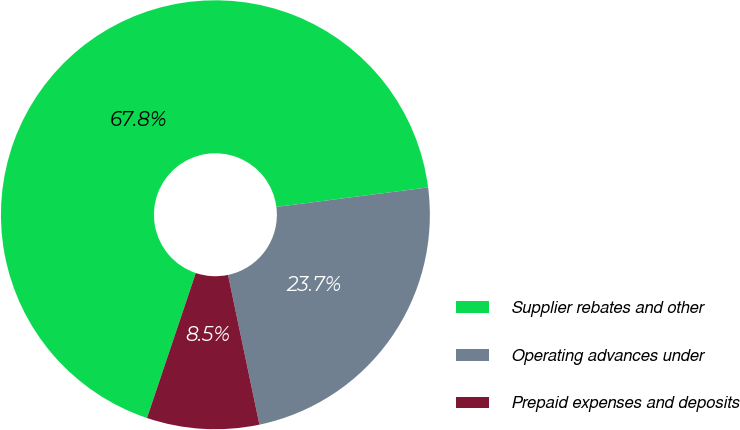<chart> <loc_0><loc_0><loc_500><loc_500><pie_chart><fcel>Supplier rebates and other<fcel>Operating advances under<fcel>Prepaid expenses and deposits<nl><fcel>67.79%<fcel>23.74%<fcel>8.46%<nl></chart> 